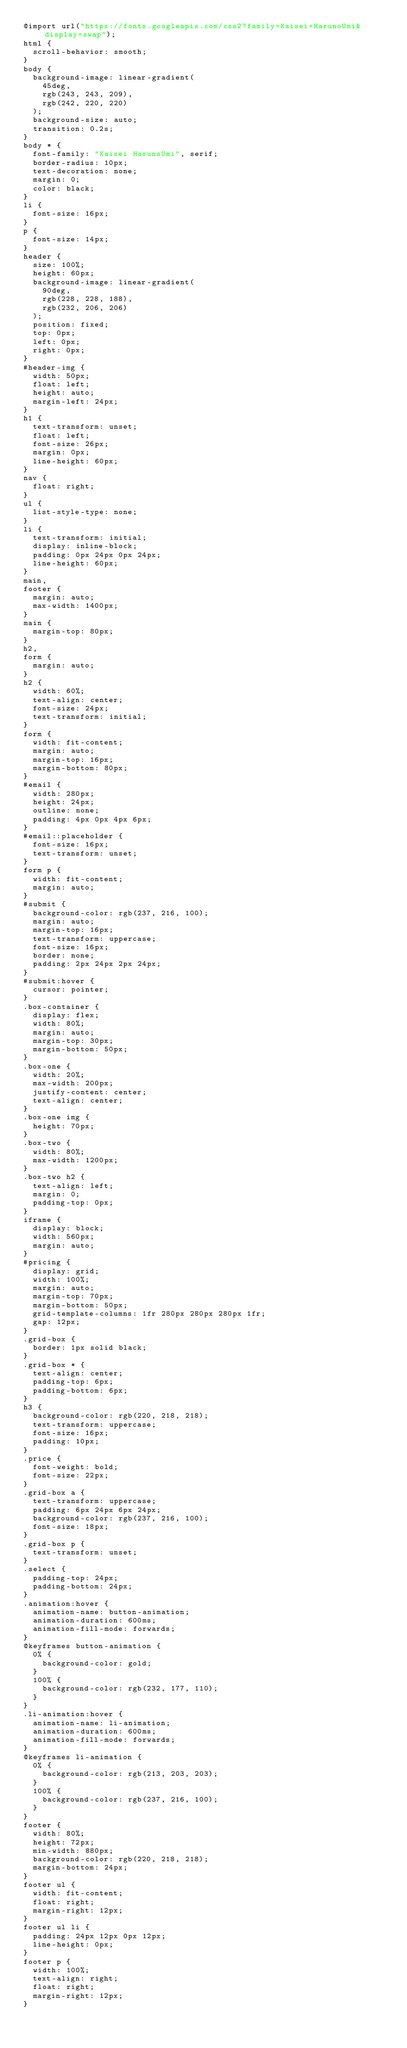<code> <loc_0><loc_0><loc_500><loc_500><_CSS_>@import url("https://fonts.googleapis.com/css2?family=Kaisei+HarunoUmi&display=swap");
html {
  scroll-behavior: smooth;
}
body {
  background-image: linear-gradient(
    45deg,
    rgb(243, 243, 209),
    rgb(242, 220, 220)
  );
  background-size: auto;
  transition: 0.2s;
}
body * {
  font-family: "Kaisei HarunoUmi", serif;
  border-radius: 10px;
  text-decoration: none;
  margin: 0;
  color: black;
}
li {
  font-size: 16px;
}
p {
  font-size: 14px;
}
header {
  size: 100%;
  height: 60px;
  background-image: linear-gradient(
    90deg,
    rgb(228, 228, 188),
    rgb(232, 206, 206)
  );
  position: fixed;
  top: 0px;
  left: 0px;
  right: 0px;
}
#header-img {
  width: 50px;
  float: left;
  height: auto;
  margin-left: 24px;
}
h1 {
  text-transform: unset;
  float: left;
  font-size: 26px;
  margin: 0px;
  line-height: 60px;
}
nav {
  float: right;
}
ul {
  list-style-type: none;
}
li {
  text-transform: initial;
  display: inline-block;
  padding: 0px 24px 0px 24px;
  line-height: 60px;
}
main,
footer {
  margin: auto;
  max-width: 1400px;
}
main {
  margin-top: 80px;
}
h2,
form {
  margin: auto;
}
h2 {
  width: 60%;
  text-align: center;
  font-size: 24px;
  text-transform: initial;
}
form {
  width: fit-content;
  margin: auto;
  margin-top: 16px;
  margin-bottom: 80px;
}
#email {
  width: 280px;
  height: 24px;
  outline: none;
  padding: 4px 0px 4px 6px;
}
#email::placeholder {
  font-size: 16px;
  text-transform: unset;
}
form p {
  width: fit-content;
  margin: auto;
}
#submit {
  background-color: rgb(237, 216, 100);
  margin: auto;
  margin-top: 16px;
  text-transform: uppercase;
  font-size: 16px;
  border: none;
  padding: 2px 24px 2px 24px;
}
#submit:hover {
  cursor: pointer;
}
.box-container {
  display: flex;
  width: 80%;
  margin: auto;
  margin-top: 30px;
  margin-bottom: 50px;
}
.box-one {
  width: 20%;
  max-width: 200px;
  justify-content: center;
  text-align: center;
}
.box-one img {
  height: 70px;
}
.box-two {
  width: 80%;
  max-width: 1200px;
}
.box-two h2 {
  text-align: left;
  margin: 0;
  padding-top: 0px;
}
iframe {
  display: block;
  width: 560px;
  margin: auto;
}
#pricing {
  display: grid;
  width: 100%;
  margin: auto;
  margin-top: 70px;
  margin-bottom: 50px;
  grid-template-columns: 1fr 280px 280px 280px 1fr;
  gap: 12px;
}
.grid-box {
  border: 1px solid black;
}
.grid-box * {
  text-align: center;
  padding-top: 6px;
  padding-bottom: 6px;
}
h3 {
  background-color: rgb(220, 218, 218);
  text-transform: uppercase;
  font-size: 16px;
  padding: 10px;
}
.price {
  font-weight: bold;
  font-size: 22px;
}
.grid-box a {
  text-transform: uppercase;
  padding: 6px 24px 6px 24px;
  background-color: rgb(237, 216, 100);
  font-size: 18px;
}
.grid-box p {
  text-transform: unset;
}
.select {
  padding-top: 24px;
  padding-bottom: 24px;
}
.animation:hover {
  animation-name: button-animation;
  animation-duration: 600ms;
  animation-fill-mode: forwards;
}
@keyframes button-animation {
  0% {
    background-color: gold;
  }
  100% {
    background-color: rgb(232, 177, 110);
  }
}
.li-animation:hover {
  animation-name: li-animation;
  animation-duration: 600ms;
  animation-fill-mode: forwards;
}
@keyframes li-animation {
  0% {
    background-color: rgb(213, 203, 203);
  }
  100% {
    background-color: rgb(237, 216, 100);
  }
}
footer {
  width: 80%;
  height: 72px;
  min-width: 880px;
  background-color: rgb(220, 218, 218);
  margin-bottom: 24px;
}
footer ul {
  width: fit-content;
  float: right;
  margin-right: 12px;
}
footer ul li {
  padding: 24px 12px 0px 12px;
  line-height: 0px;
}
footer p {
  width: 100%;
  text-align: right;
  float: right;
  margin-right: 12px;
}</code> 